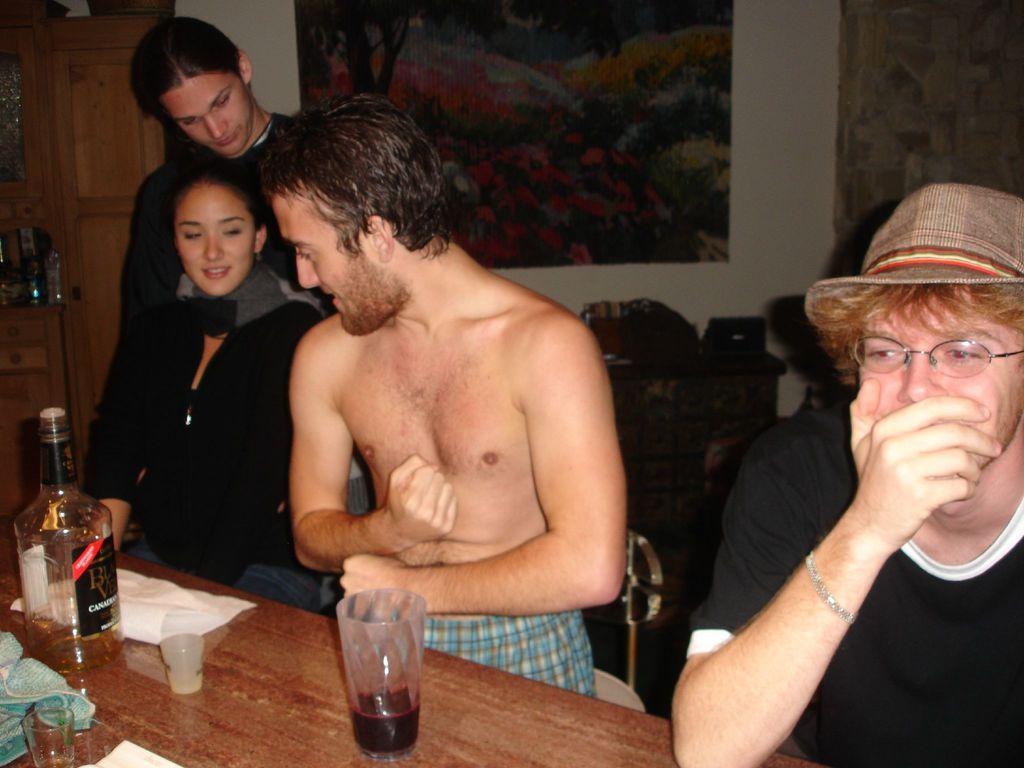Please provide a concise description of this image. In this image there are four persons on the right side there is one person who is sitting and he is wearing spectacles and cap beside that person another person who is sitting beside a that person another woman who is sitting and she is wearing a black jacket beside that woman another person i standing on the background there is wall on the wall there is one photo frame on the left side there is one door in the bottom there is one table o the table there are tissue papers, bottles, glasses and some clothes are there on the table. 